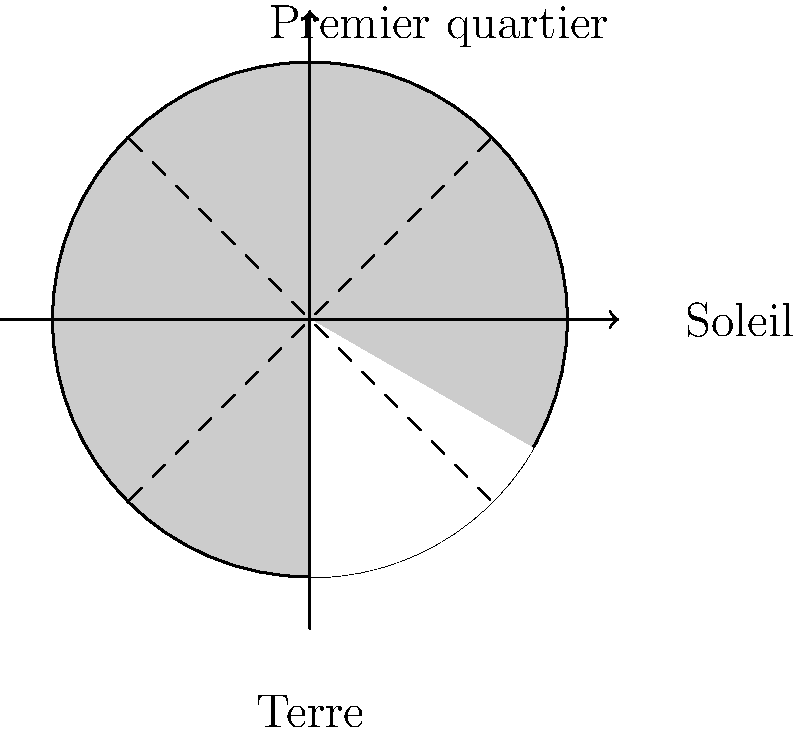Sacrebleu ! En tant que fan de sport français, vous savez que la précision est cruciale. Imaginez que vous observez la Lune depuis Paris lors d'un match de football nocturne. Quelle phase lunaire est représentée dans l'image, et comment apparaîtrait-elle depuis la Terre ? Pour comprendre la phase lunaire représentée, suivons ces étapes :

1. Orientation : La Terre est au centre, le Soleil à droite.

2. Illumination : La moitié droite de la Lune est éclairée par le Soleil.

3. Angle : La Lune est à environ 90° par rapport à la ligne Terre-Soleil.

4. Visibilité : Depuis la Terre, nous voyons la moitié droite de la face visible de la Lune illuminée.

5. Phase : Cette configuration correspond au premier quartier de Lune.

6. Apparence : Depuis la Terre, la Lune apparaîtrait comme un "D" lumineux dans le ciel nocturne.

7. Timing : Le premier quartier se produit environ 7 jours après la nouvelle Lune.

8. Visibilité sportive : Pour un match de football nocturne à Paris, cette phase offrirait un éclairage naturel partiel, créant une atmosphère unique.
Answer: Premier quartier, apparence en "D" 